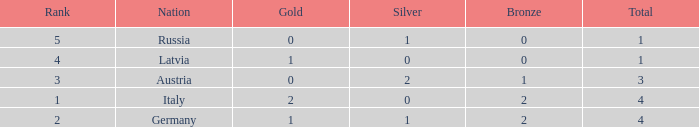What is the average number of silver medals for countries with 0 gold and rank under 3? None. 